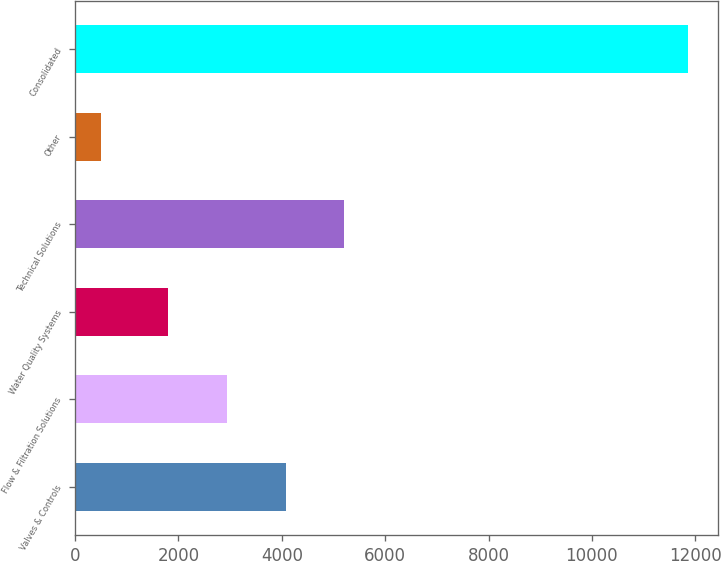Convert chart to OTSL. <chart><loc_0><loc_0><loc_500><loc_500><bar_chart><fcel>Valves & Controls<fcel>Flow & Filtration Solutions<fcel>Water Quality Systems<fcel>Technical Solutions<fcel>Other<fcel>Consolidated<nl><fcel>4072.94<fcel>2937.32<fcel>1801.7<fcel>5208.56<fcel>500.8<fcel>11857<nl></chart> 